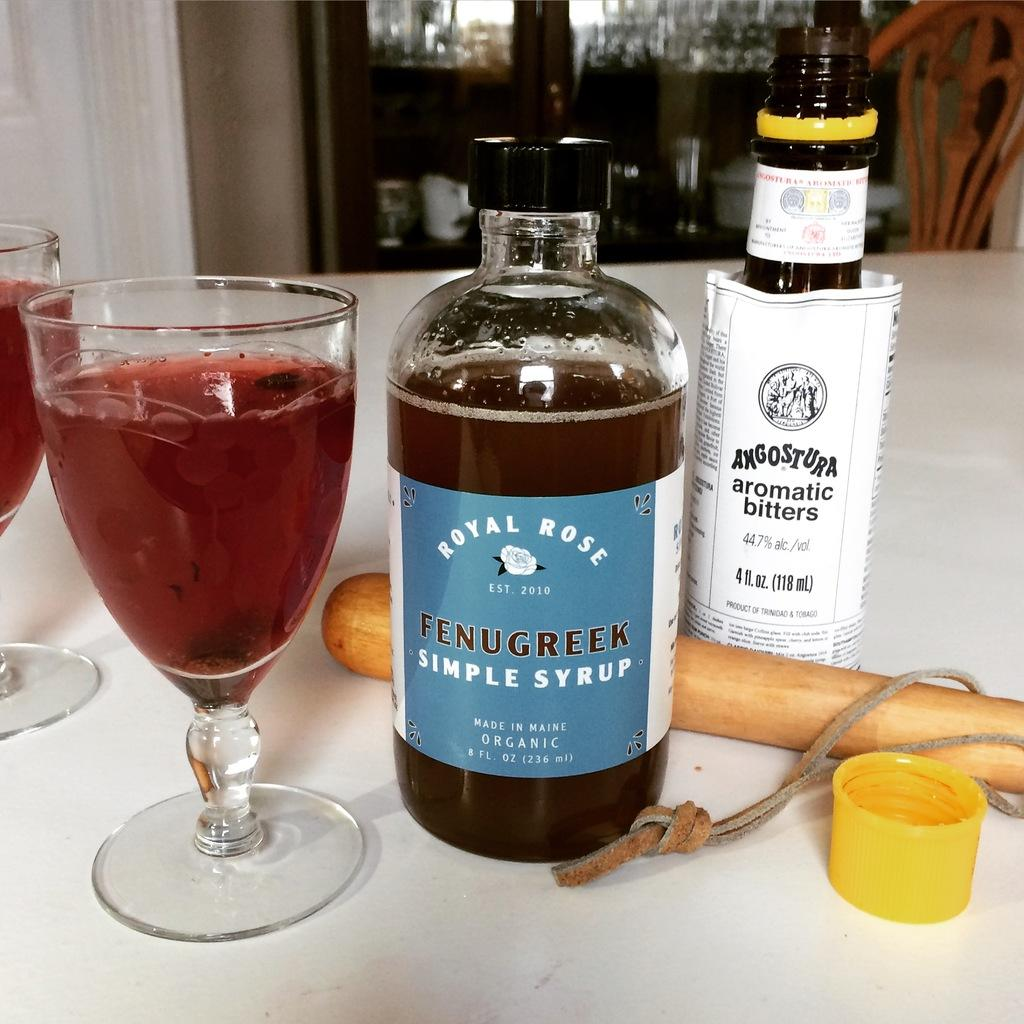<image>
Share a concise interpretation of the image provided. A bottle of Royal Rose Simple Syrup is on a table next to a bottle of bitters. 